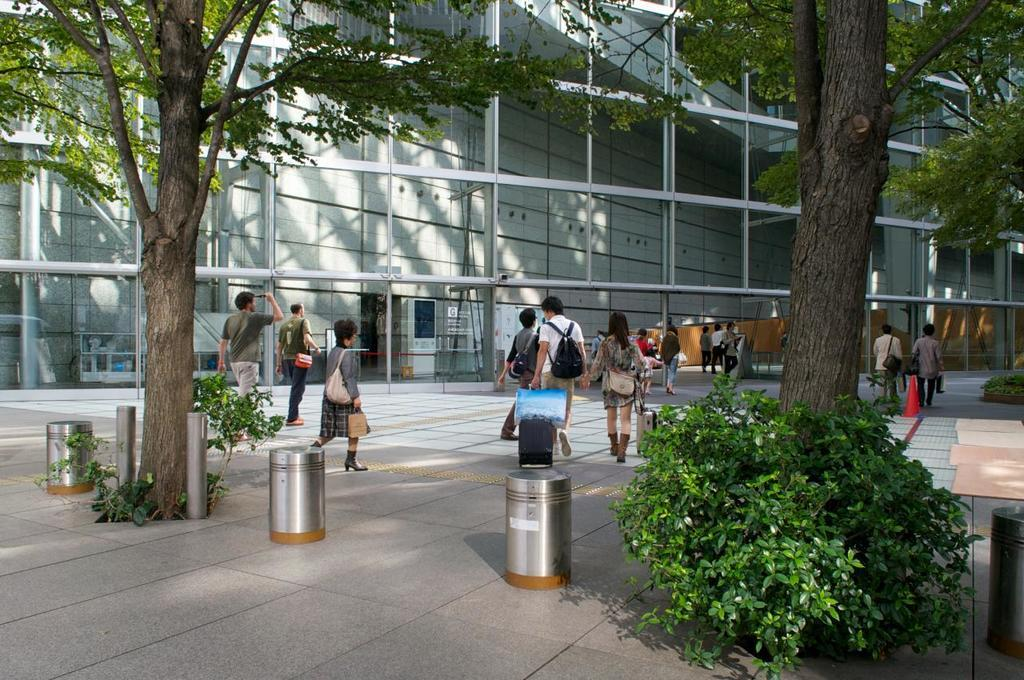What type of building is in the image? There is a glass building in the image. What are the people in the image doing? The people are walking on a path in the image. What type of vegetation is present in the image? Trees and plants are visible in the image. What are the small poles in the image used for? The purpose of the small poles in the image is not specified, but they could be used for various purposes such as signage or lighting. How many bins are in the image? There are four bins in the image. What color is the crayon being used by the men in the image? There are no men or crayons present in the image. What activity are the men participating in while holding the crayons in the image? There are no men or crayons present in the image, so no such activity can be observed. 